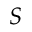Convert formula to latex. <formula><loc_0><loc_0><loc_500><loc_500>S</formula> 